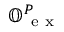Convert formula to latex. <formula><loc_0><loc_0><loc_500><loc_500>\mathbb { O } _ { e x } ^ { P }</formula> 